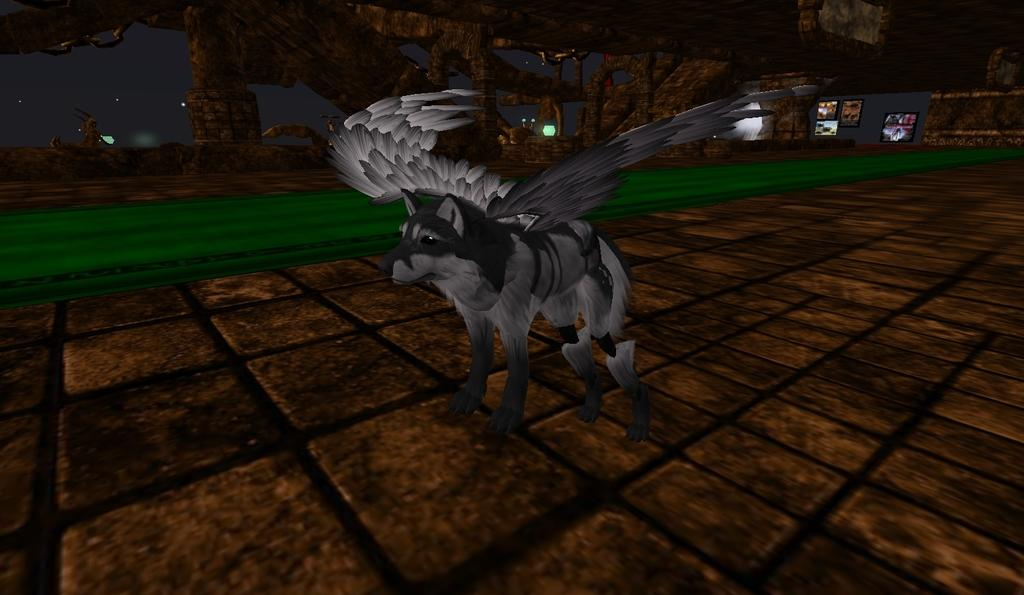What type of scene is depicted in the image? The image contains an animated scene. Can you identify any animals in the image? Yes, there is a fox in the image. What is unique about the fox in the image? The fox has wings in the image. What color is the fox in the image? The fox is in grey color. How many waves can be seen in the image? There are no waves present in the image; it features an animated scene with a fox. What type of sticks are being used by the fox in the image? There are no sticks present in the image; the fox has wings instead. 